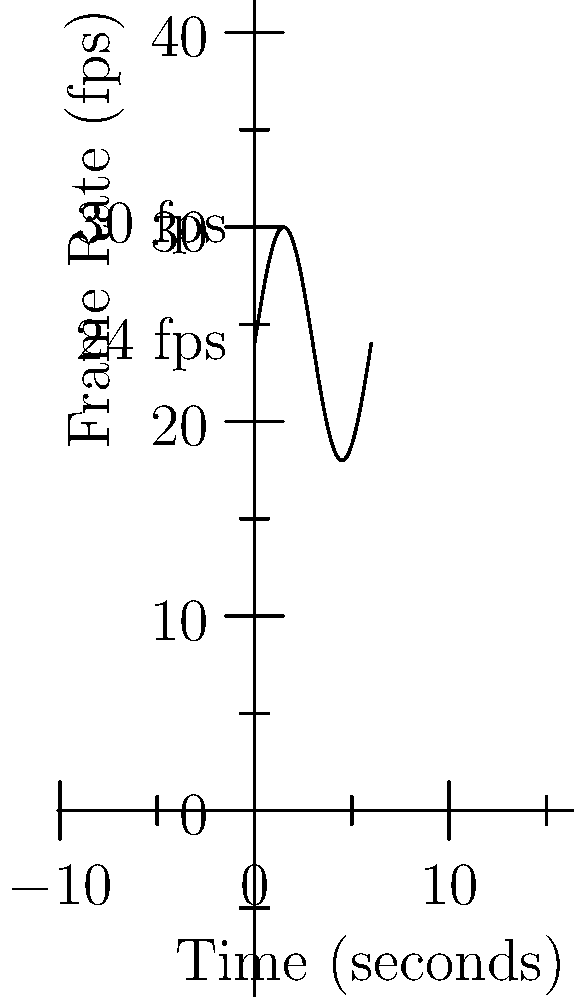A new film camera uses variable frame rates to create a unique visual effect. The frame rate oscillates between 24 and 30 fps over a 6-second cycle, following a sinusoidal pattern as shown in the graph. If a scene is shot for 18 seconds, how many frames will be captured? To solve this problem, we need to calculate the average frame rate over the 18-second period and then multiply it by the total time.

1) The frame rate function can be described as:
   $f(t) = 24 + 6\sin(\frac{\pi t}{3})$

2) To find the average frame rate, we need to integrate this function over one complete cycle (6 seconds) and divide by the cycle length:

   $\text{Average frame rate} = \frac{1}{6}\int_0^6 (24 + 6\sin(\frac{\pi t}{3})) dt$

3) Solving this integral:
   $= \frac{1}{6}[24t - \frac{18}{\pi/3}\cos(\frac{\pi t}{3})]_0^6$
   $= \frac{1}{6}[(144 - \frac{18}{\pi/3}\cos(2\pi)) - (0 - \frac{18}{\pi/3}\cos(0))]$
   $= \frac{1}{6}[144 - \frac{18}{\pi/3} + \frac{18}{\pi/3}]$
   $= 24$ fps

4) The average frame rate over any number of complete cycles will always be 24 fps.

5) For 18 seconds (3 complete cycles), the total number of frames is:
   $24 \text{ fps} \times 18 \text{ seconds} = 432 \text{ frames}$

Therefore, 432 frames will be captured in 18 seconds.
Answer: 432 frames 